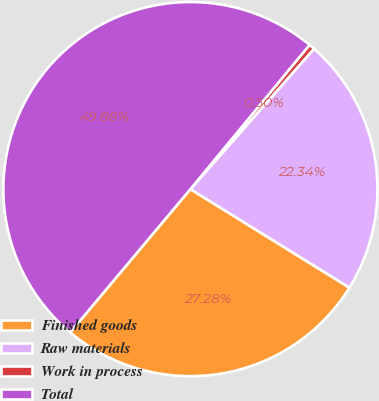Convert chart to OTSL. <chart><loc_0><loc_0><loc_500><loc_500><pie_chart><fcel>Finished goods<fcel>Raw materials<fcel>Work in process<fcel>Total<nl><fcel>27.28%<fcel>22.34%<fcel>0.5%<fcel>49.88%<nl></chart> 